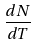Convert formula to latex. <formula><loc_0><loc_0><loc_500><loc_500>\frac { d N } { d T }</formula> 